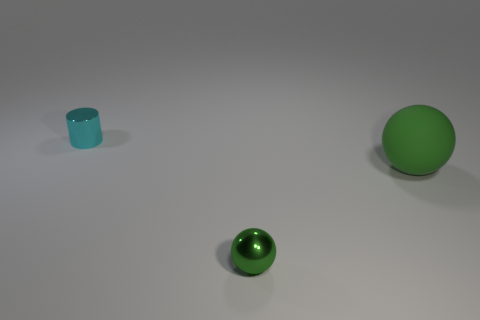Are there any other things that are the same material as the large sphere?
Ensure brevity in your answer.  No. The object in front of the green ball that is right of the green metallic object is what color?
Your response must be concise. Green. What size is the sphere that is the same material as the cyan thing?
Your answer should be very brief. Small. How many other matte objects have the same shape as the large thing?
Ensure brevity in your answer.  0. How many things are either green spheres that are in front of the large matte thing or tiny metal objects that are on the right side of the cyan object?
Offer a terse response. 1. There is a thing that is in front of the large rubber sphere; what number of green balls are right of it?
Offer a very short reply. 1. There is a metal thing that is right of the cyan metallic thing; does it have the same shape as the green object that is behind the tiny green metallic thing?
Provide a succinct answer. Yes. There is another small thing that is the same color as the rubber object; what shape is it?
Offer a very short reply. Sphere. Is there a tiny cyan thing made of the same material as the big green sphere?
Your answer should be very brief. No. How many metallic objects are tiny cyan cylinders or big blue balls?
Provide a short and direct response. 1. 